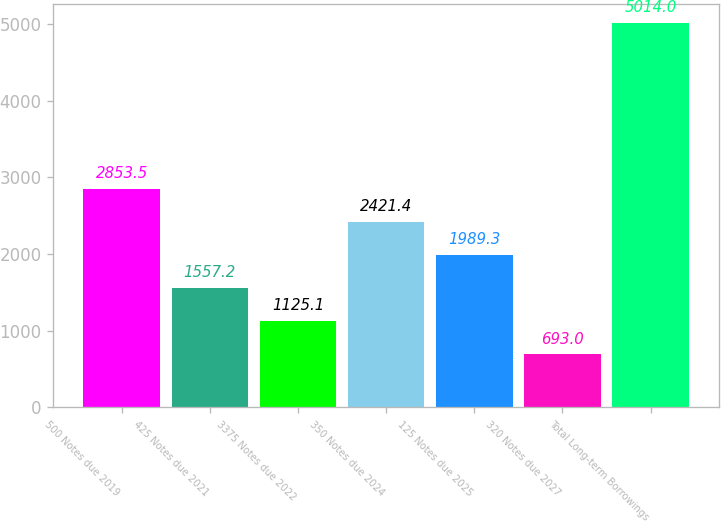Convert chart. <chart><loc_0><loc_0><loc_500><loc_500><bar_chart><fcel>500 Notes due 2019<fcel>425 Notes due 2021<fcel>3375 Notes due 2022<fcel>350 Notes due 2024<fcel>125 Notes due 2025<fcel>320 Notes due 2027<fcel>Total Long-term Borrowings<nl><fcel>2853.5<fcel>1557.2<fcel>1125.1<fcel>2421.4<fcel>1989.3<fcel>693<fcel>5014<nl></chart> 